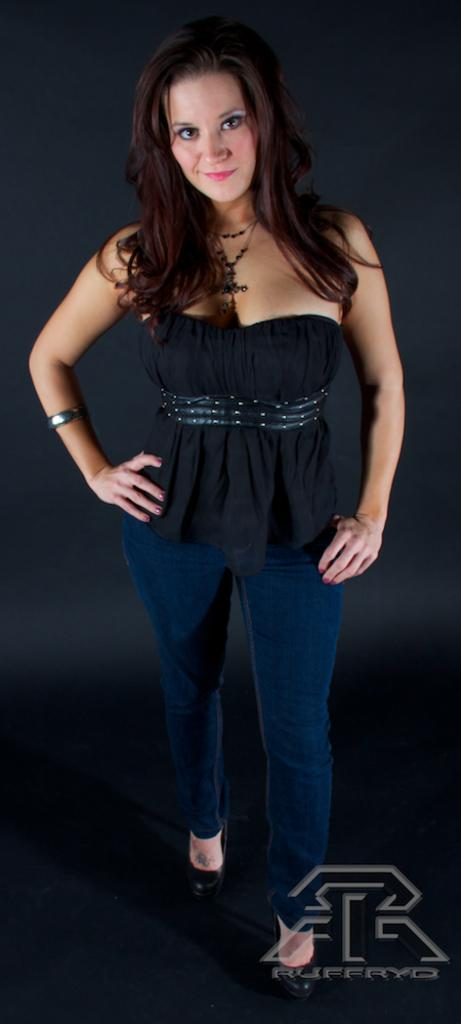Who is present in the image? There is a woman in the image. What is the woman doing in the image? The woman is smiling in the image. What can be observed about the background of the image? The background of the image is dark. Where is the logo located in the image? The logo is in the bottom right corner of the image. What is written on the logo? There is text on the logo. How many beans are present in the image? There are no beans visible in the image. Are the woman's sisters also present in the image? The provided facts do not mention any sisters, so we cannot determine if they are present in the image. 